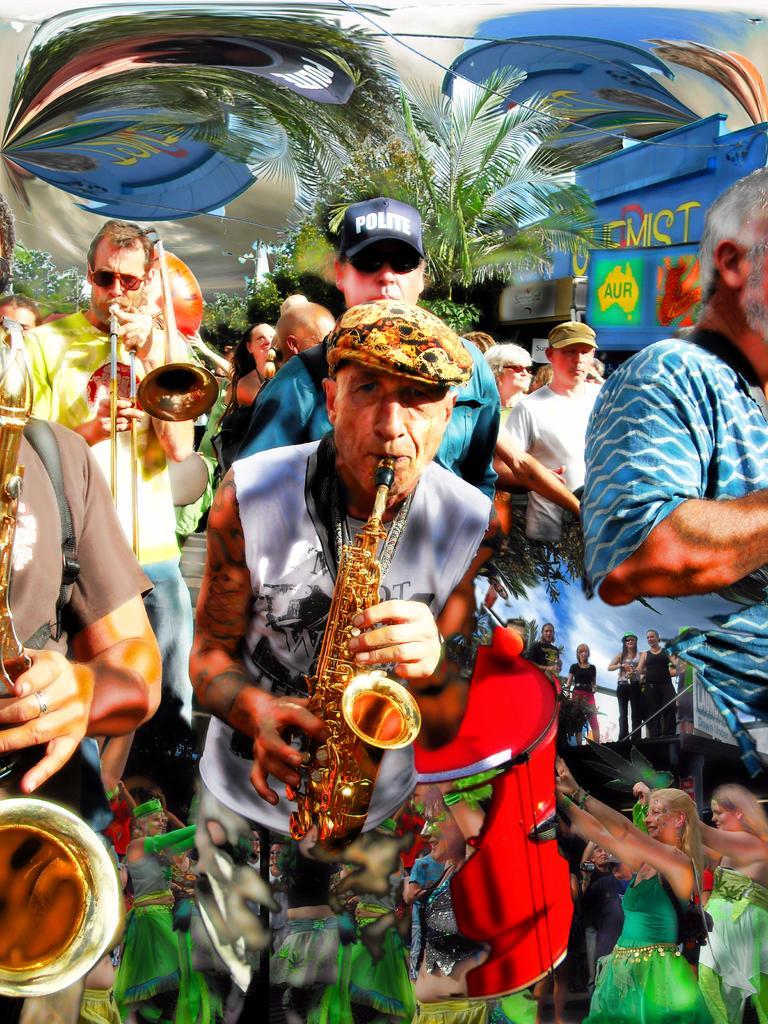How would you summarize this image in a sentence or two? In this image it seems like a painting in which there is a person in the middle who is playing the trumpet by holding the drum. In the background there are few other people who are playing the musical instruments. In the background there are few girls who are wearing the green dress are standing on the floor. There are trees in the background. 